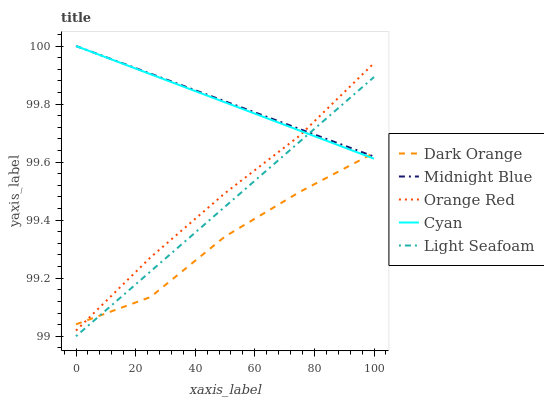Does Cyan have the minimum area under the curve?
Answer yes or no. No. Does Cyan have the maximum area under the curve?
Answer yes or no. No. Is Light Seafoam the smoothest?
Answer yes or no. No. Is Light Seafoam the roughest?
Answer yes or no. No. Does Cyan have the lowest value?
Answer yes or no. No. Does Light Seafoam have the highest value?
Answer yes or no. No. Is Light Seafoam less than Orange Red?
Answer yes or no. Yes. Is Orange Red greater than Light Seafoam?
Answer yes or no. Yes. Does Light Seafoam intersect Orange Red?
Answer yes or no. No. 